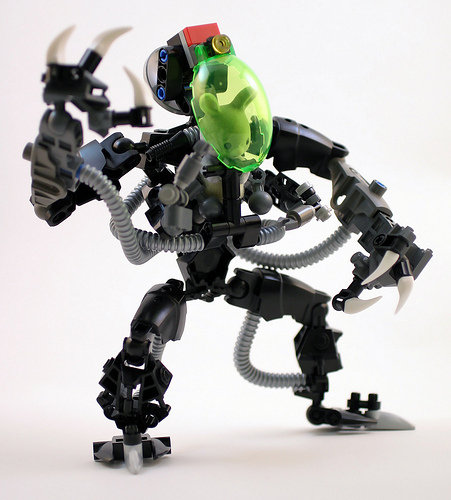<image>
Can you confirm if the rabbit is in the robot? Yes. The rabbit is contained within or inside the robot, showing a containment relationship. 